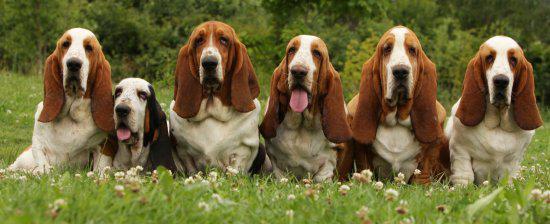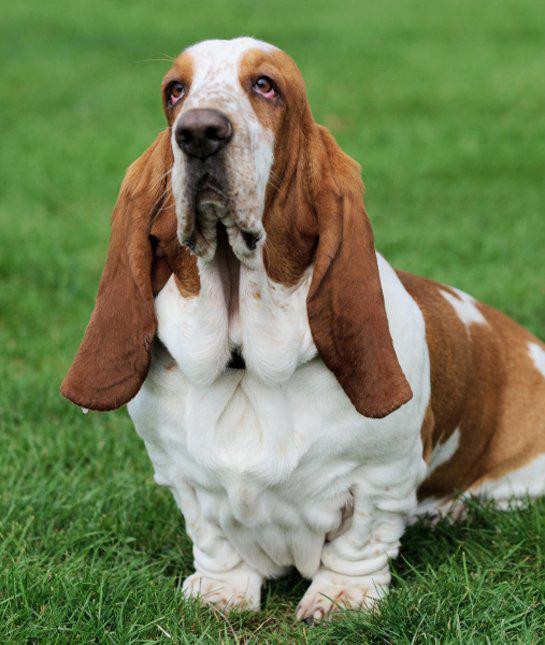The first image is the image on the left, the second image is the image on the right. Assess this claim about the two images: "There are two dogs total on both images.". Correct or not? Answer yes or no. No. The first image is the image on the left, the second image is the image on the right. Considering the images on both sides, is "One of the images contains two or more basset hounds." valid? Answer yes or no. Yes. 